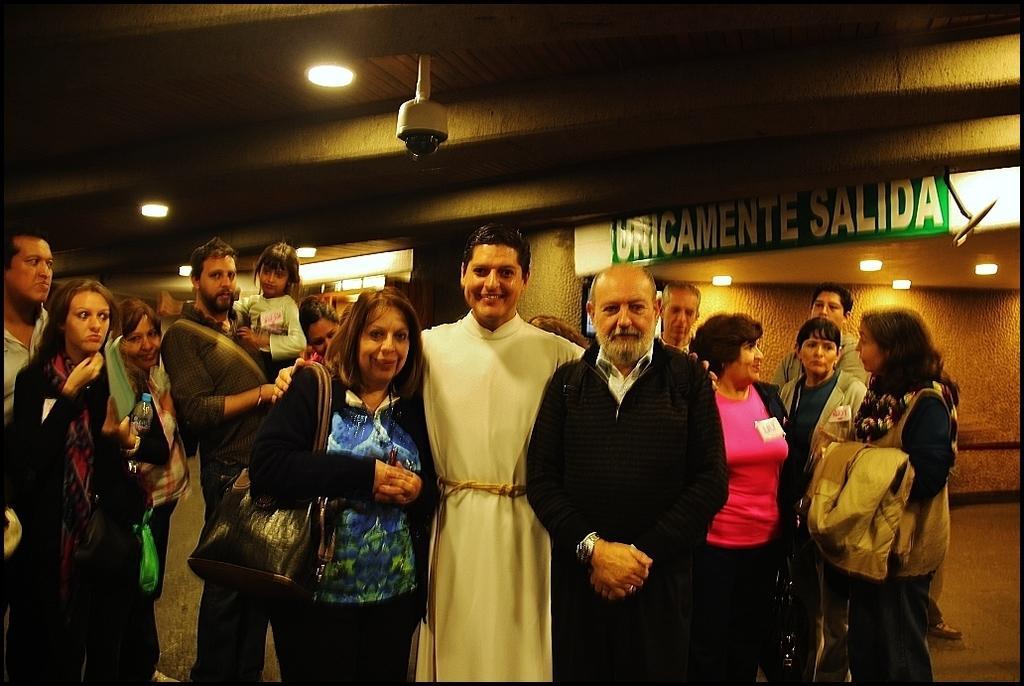Can you describe this image briefly? In this image, we can see persons standing and wearing clothes. There is a camera at the top of the image. There are lights on ceiling. There is a board on the right side of the image. 